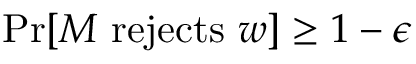<formula> <loc_0><loc_0><loc_500><loc_500>{ P r } [ M { r e j e c t s } w ] \geq 1 - \epsilon</formula> 